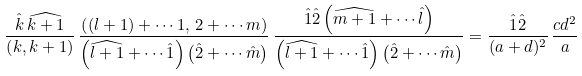<formula> <loc_0><loc_0><loc_500><loc_500>\frac { \hat { k } \, \widehat { k + 1 } } { \left ( k , k + 1 \right ) } \, \frac { \left ( ( l + 1 ) + \cdots 1 , \, 2 + \cdots m \right ) } { \left ( \widehat { l + 1 } + \cdots \hat { 1 } \right ) \left ( \hat { 2 } + \cdots \hat { m } \right ) } \, \frac { \hat { 1 } \hat { 2 } \left ( \widehat { m + 1 } + \cdots \hat { l } \right ) } { \left ( \widehat { l + 1 } + \cdots \hat { 1 } \right ) \left ( \hat { 2 } + \cdots \hat { m } \right ) } = \frac { \hat { 1 } \hat { 2 } } { ( a + d ) ^ { 2 } } \, \frac { c d ^ { 2 } } { a }</formula> 